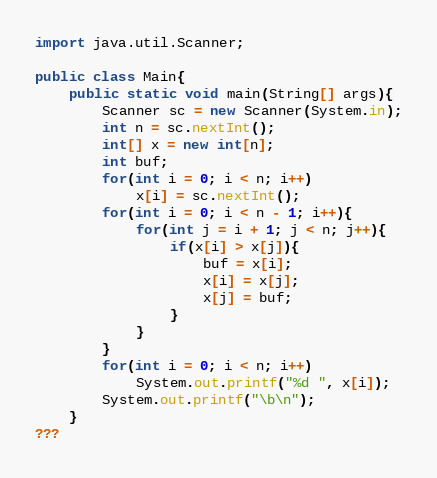<code> <loc_0><loc_0><loc_500><loc_500><_Java_>import java.util.Scanner;

public class Main{
	public static void main(String[] args){
		Scanner sc = new Scanner(System.in);
		int n = sc.nextInt();
		int[] x = new int[n];
		int buf;
		for(int i = 0; i < n; i++)
			x[i] = sc.nextInt();
		for(int i = 0; i < n - 1; i++){
			for(int j = i + 1; j < n; j++){
				if(x[i] > x[j]){
					buf = x[i];
					x[i] = x[j];
					x[j] = buf;
				}
			}
		}
		for(int i = 0; i < n; i++)
			System.out.printf("%d ", x[i]);
		System.out.printf("\b\n");
	}
???</code> 